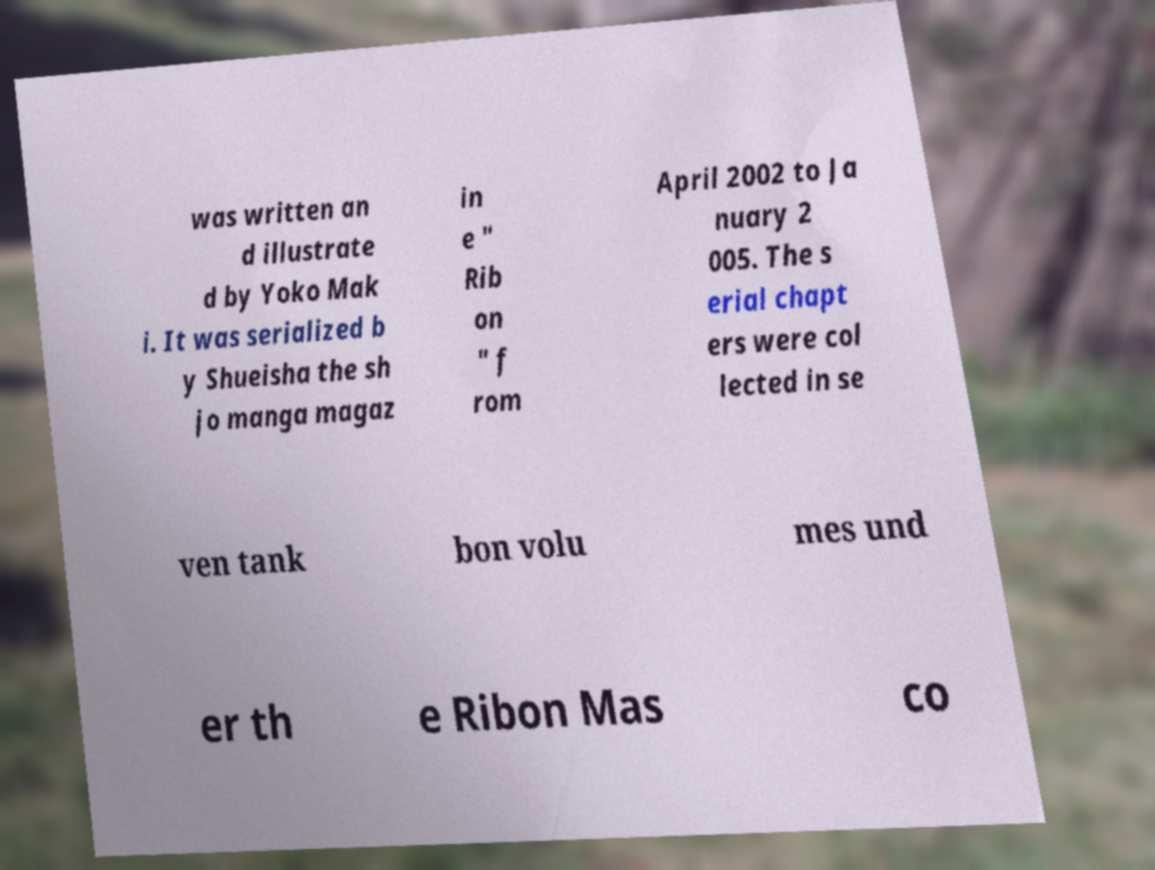What messages or text are displayed in this image? I need them in a readable, typed format. was written an d illustrate d by Yoko Mak i. It was serialized b y Shueisha the sh jo manga magaz in e " Rib on " f rom April 2002 to Ja nuary 2 005. The s erial chapt ers were col lected in se ven tank bon volu mes und er th e Ribon Mas co 